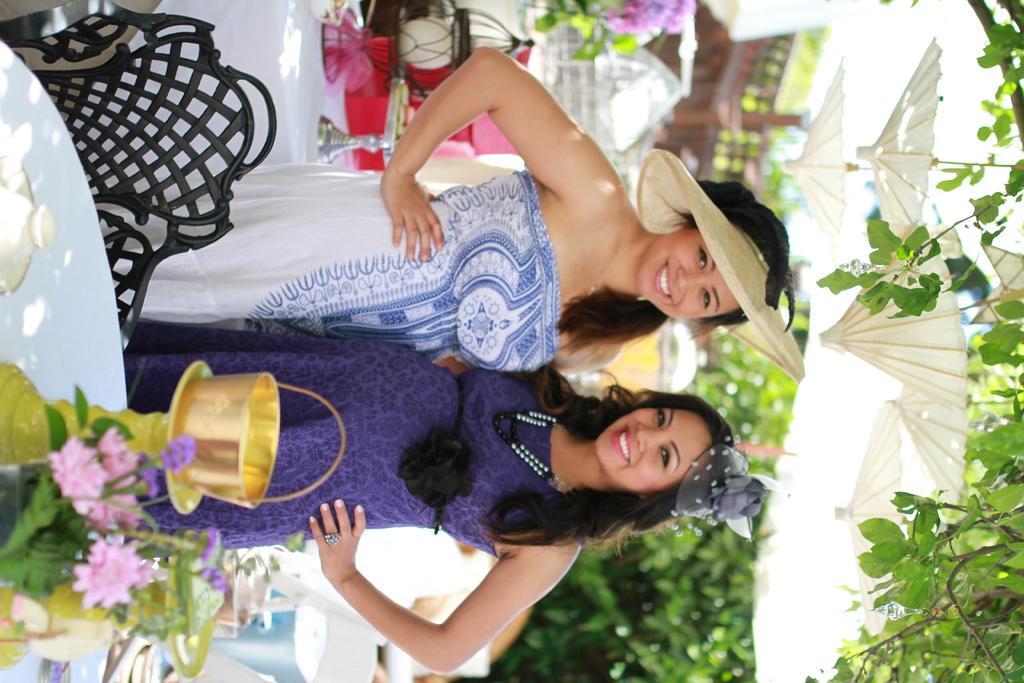Can you describe this image briefly? In this picture we can see two women and they are smiling. There are tables. On the table there is a cloth and flower vases. This is chair. In the background there are trees. 